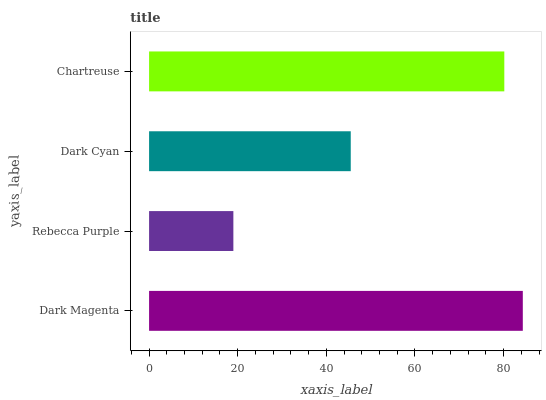Is Rebecca Purple the minimum?
Answer yes or no. Yes. Is Dark Magenta the maximum?
Answer yes or no. Yes. Is Dark Cyan the minimum?
Answer yes or no. No. Is Dark Cyan the maximum?
Answer yes or no. No. Is Dark Cyan greater than Rebecca Purple?
Answer yes or no. Yes. Is Rebecca Purple less than Dark Cyan?
Answer yes or no. Yes. Is Rebecca Purple greater than Dark Cyan?
Answer yes or no. No. Is Dark Cyan less than Rebecca Purple?
Answer yes or no. No. Is Chartreuse the high median?
Answer yes or no. Yes. Is Dark Cyan the low median?
Answer yes or no. Yes. Is Rebecca Purple the high median?
Answer yes or no. No. Is Dark Magenta the low median?
Answer yes or no. No. 